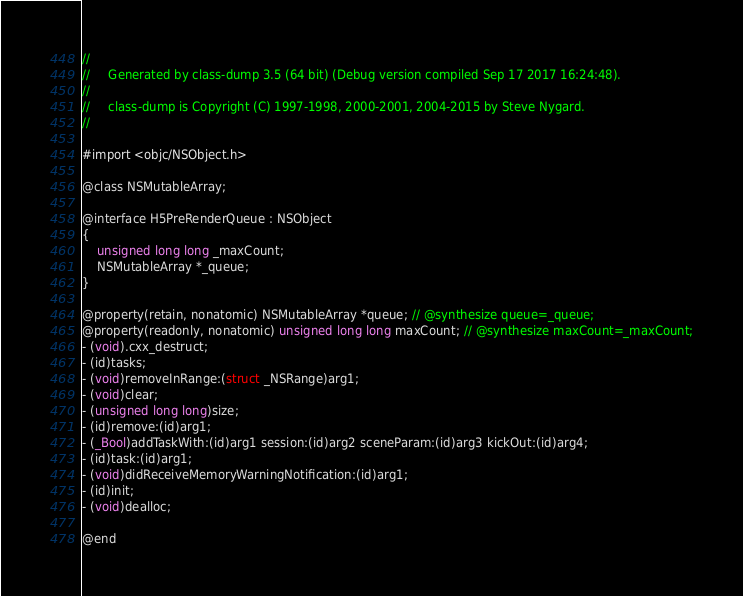<code> <loc_0><loc_0><loc_500><loc_500><_C_>//
//     Generated by class-dump 3.5 (64 bit) (Debug version compiled Sep 17 2017 16:24:48).
//
//     class-dump is Copyright (C) 1997-1998, 2000-2001, 2004-2015 by Steve Nygard.
//

#import <objc/NSObject.h>

@class NSMutableArray;

@interface H5PreRenderQueue : NSObject
{
    unsigned long long _maxCount;
    NSMutableArray *_queue;
}

@property(retain, nonatomic) NSMutableArray *queue; // @synthesize queue=_queue;
@property(readonly, nonatomic) unsigned long long maxCount; // @synthesize maxCount=_maxCount;
- (void).cxx_destruct;
- (id)tasks;
- (void)removeInRange:(struct _NSRange)arg1;
- (void)clear;
- (unsigned long long)size;
- (id)remove:(id)arg1;
- (_Bool)addTaskWith:(id)arg1 session:(id)arg2 sceneParam:(id)arg3 kickOut:(id)arg4;
- (id)task:(id)arg1;
- (void)didReceiveMemoryWarningNotification:(id)arg1;
- (id)init;
- (void)dealloc;

@end

</code> 